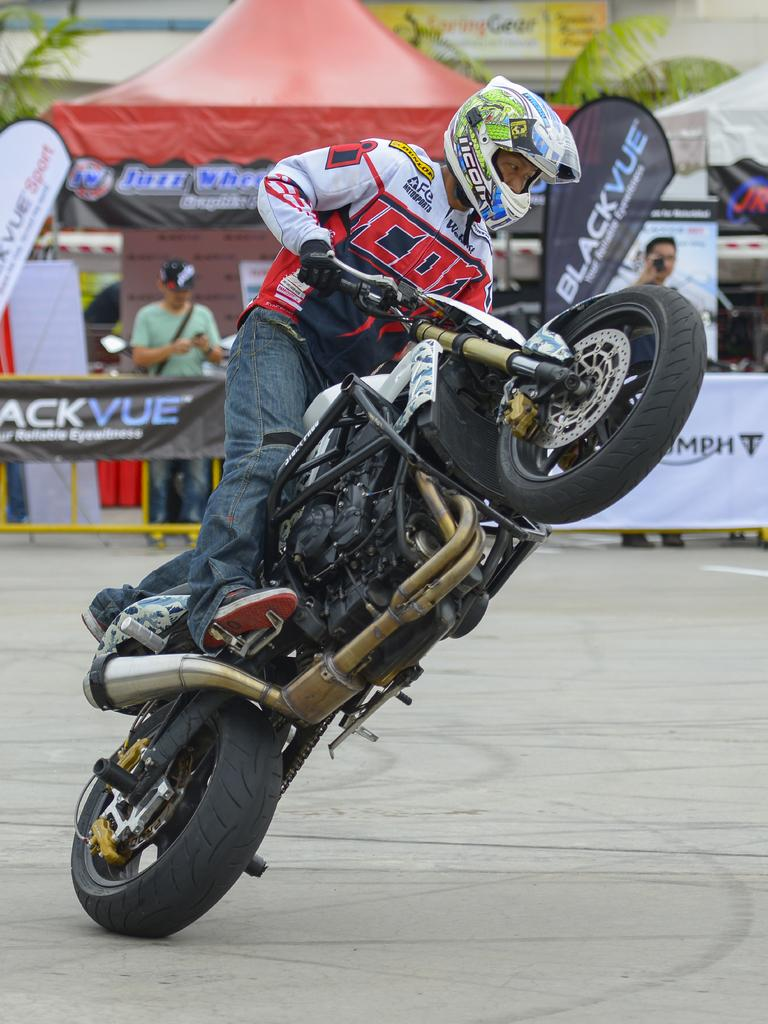What is the person in the image holding? The person is holding a bike in the image. What can be seen in the background of the image? There are people, banners, trees, a tent, and other objects visible in the background of the image. How many people are visible in the background of the image? There are people visible in the background of the image, but the exact number cannot be determined from the provided facts. What type of grass is being used to repair the sail in the image? There is no grass or sail present in the image. What tool is the person using to fix the wrench in the image? There is no wrench present in the image, and the person is holding a bike, not a tool. 